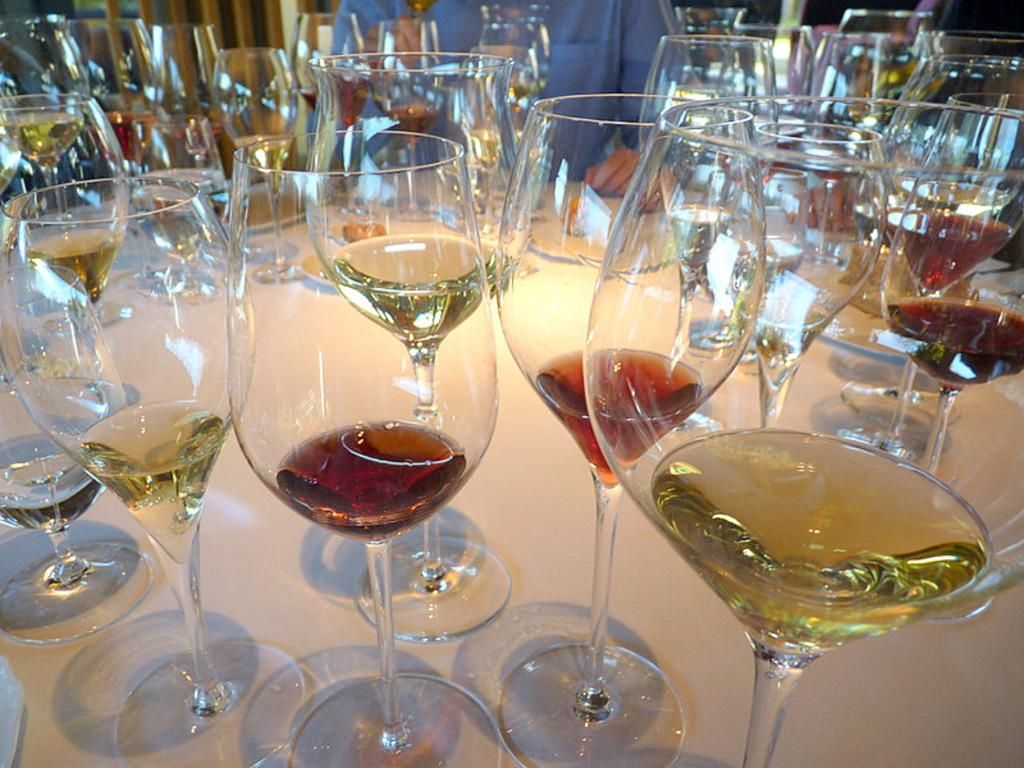What objects are present in the image? There are glasses in the image. Can you describe the contents of the glasses? There is a drink in the glasses. Is there anyone else visible in the image besides the glasses? Yes, there is a person in the background of the image. What type of industry can be seen in the background of the image? There is no industry visible in the background of the image; it only shows a person in the background. 